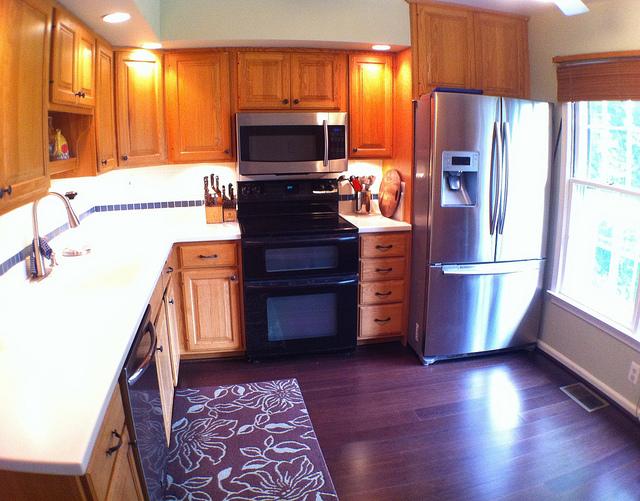Are those oak cabinets?
Short answer required. Yes. Does the fridge make ice?
Give a very brief answer. Yes. What color is the microwave?
Answer briefly. Silver. 